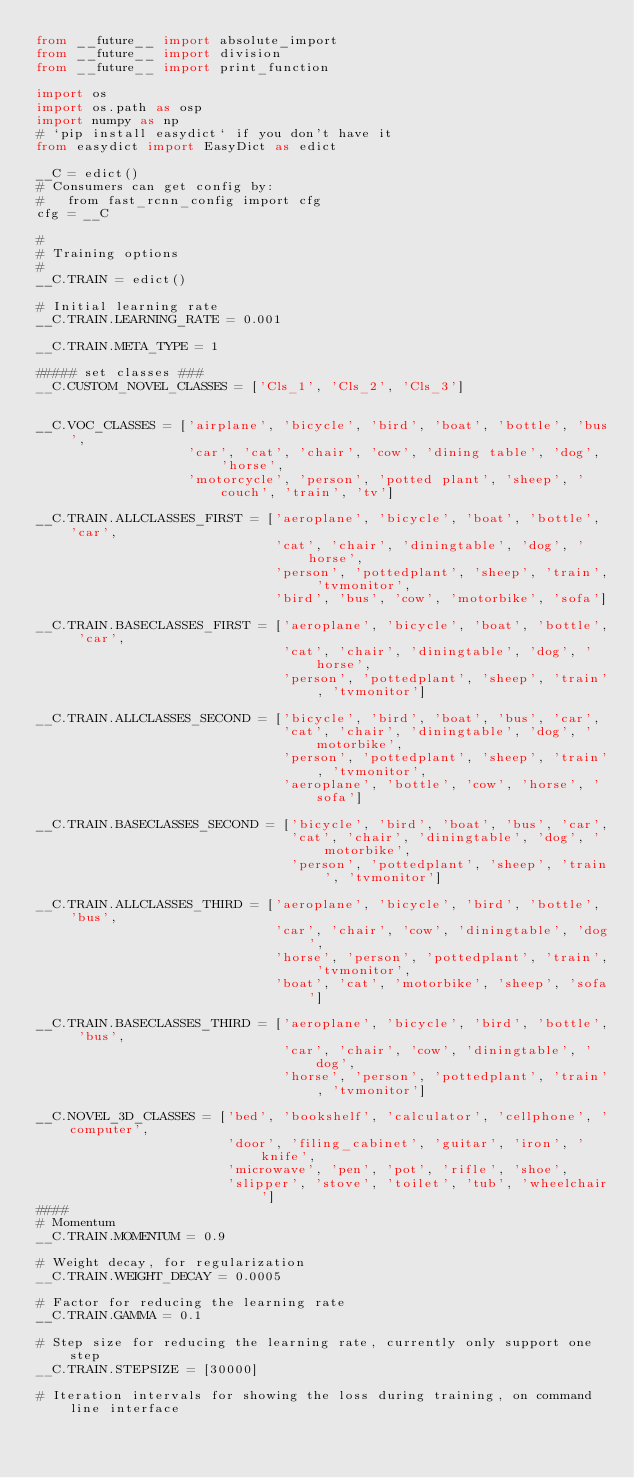Convert code to text. <code><loc_0><loc_0><loc_500><loc_500><_Python_>from __future__ import absolute_import
from __future__ import division
from __future__ import print_function

import os
import os.path as osp
import numpy as np
# `pip install easydict` if you don't have it
from easydict import EasyDict as edict

__C = edict()
# Consumers can get config by:
#   from fast_rcnn_config import cfg
cfg = __C

#
# Training options
#
__C.TRAIN = edict()

# Initial learning rate
__C.TRAIN.LEARNING_RATE = 0.001

__C.TRAIN.META_TYPE = 1

##### set classes ###
__C.CUSTOM_NOVEL_CLASSES = ['Cls_1', 'Cls_2', 'Cls_3']


__C.VOC_CLASSES = ['airplane', 'bicycle', 'bird', 'boat', 'bottle', 'bus',
                   'car', 'cat', 'chair', 'cow', 'dining table', 'dog', 'horse',
                   'motorcycle', 'person', 'potted plant', 'sheep', 'couch', 'train', 'tv']

__C.TRAIN.ALLCLASSES_FIRST = ['aeroplane', 'bicycle', 'boat', 'bottle', 'car',
                              'cat', 'chair', 'diningtable', 'dog', 'horse',
                              'person', 'pottedplant', 'sheep', 'train', 'tvmonitor',
                              'bird', 'bus', 'cow', 'motorbike', 'sofa']

__C.TRAIN.BASECLASSES_FIRST = ['aeroplane', 'bicycle', 'boat', 'bottle', 'car',
                               'cat', 'chair', 'diningtable', 'dog', 'horse',
                               'person', 'pottedplant', 'sheep', 'train', 'tvmonitor']

__C.TRAIN.ALLCLASSES_SECOND = ['bicycle', 'bird', 'boat', 'bus', 'car',
                               'cat', 'chair', 'diningtable', 'dog', 'motorbike',
                               'person', 'pottedplant', 'sheep', 'train', 'tvmonitor',
                               'aeroplane', 'bottle', 'cow', 'horse', 'sofa']

__C.TRAIN.BASECLASSES_SECOND = ['bicycle', 'bird', 'boat', 'bus', 'car',
                                'cat', 'chair', 'diningtable', 'dog', 'motorbike',
                                'person', 'pottedplant', 'sheep', 'train', 'tvmonitor']

__C.TRAIN.ALLCLASSES_THIRD = ['aeroplane', 'bicycle', 'bird', 'bottle', 'bus',
                              'car', 'chair', 'cow', 'diningtable', 'dog',
                              'horse', 'person', 'pottedplant', 'train', 'tvmonitor',
                              'boat', 'cat', 'motorbike', 'sheep', 'sofa']

__C.TRAIN.BASECLASSES_THIRD = ['aeroplane', 'bicycle', 'bird', 'bottle', 'bus',
                               'car', 'chair', 'cow', 'diningtable', 'dog',
                               'horse', 'person', 'pottedplant', 'train', 'tvmonitor']

__C.NOVEL_3D_CLASSES = ['bed', 'bookshelf', 'calculator', 'cellphone', 'computer',
                        'door', 'filing_cabinet', 'guitar', 'iron', 'knife',
                        'microwave', 'pen', 'pot', 'rifle', 'shoe',
                        'slipper', 'stove', 'toilet', 'tub', 'wheelchair']
####
# Momentum
__C.TRAIN.MOMENTUM = 0.9

# Weight decay, for regularization
__C.TRAIN.WEIGHT_DECAY = 0.0005

# Factor for reducing the learning rate
__C.TRAIN.GAMMA = 0.1

# Step size for reducing the learning rate, currently only support one step
__C.TRAIN.STEPSIZE = [30000]

# Iteration intervals for showing the loss during training, on command line interface</code> 